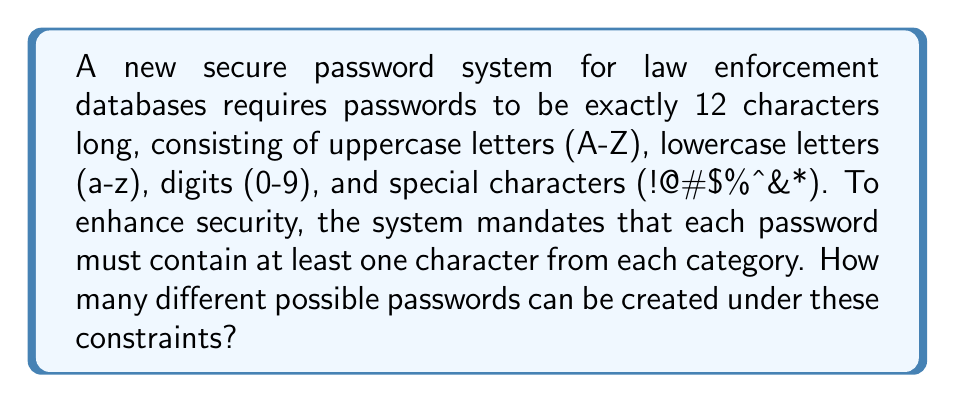Provide a solution to this math problem. Let's approach this step-by-step using the Principle of Inclusion-Exclusion:

1) First, let's count the total number of 12-character passwords without restrictions:
   $$(26 + 26 + 10 + 8)^{12} = 70^{12}$$

2) Now, we need to subtract the passwords that don't meet our criteria. Let's count the passwords missing at least one category:

   a) Missing uppercase: $$(26 + 10 + 8)^{12} = 44^{12}$$
   b) Missing lowercase: $$(26 + 10 + 8)^{12} = 44^{12}$$
   c) Missing digit: $$(26 + 26 + 8)^{12} = 60^{12}$$
   d) Missing special: $$(26 + 26 + 10)^{12} = 62^{12}$$

3) We've overcounted some passwords, so we need to add back those missing two categories:

   e) Missing uppercase and lowercase: $$(10 + 8)^{12} = 18^{12}$$
   f) Missing uppercase and digit: $$(26 + 8)^{12} = 34^{12}$$
   g) Missing uppercase and special: $$(26 + 10)^{12} = 36^{12}$$
   h) Missing lowercase and digit: $$(26 + 8)^{12} = 34^{12}$$
   i) Missing lowercase and special: $$(26 + 10)^{12} = 36^{12}$$
   j) Missing digit and special: $$(26 + 26)^{12} = 52^{12}$$

4) Now we've undercounted, so we need to subtract passwords missing three categories:

   k) Only lowercase: $$26^{12}$$
   l) Only uppercase: $$26^{12}$$
   m) Only digits: $$10^{12}$$
   n) Only special: $$8^{12}$$

5) Applying the Principle of Inclusion-Exclusion:

   $$\text{Total} = 70^{12} - (44^{12} + 44^{12} + 60^{12} + 62^{12}) + (18^{12} + 34^{12} + 36^{12} + 34^{12} + 36^{12} + 52^{12}) - (26^{12} + 26^{12} + 10^{12} + 8^{12})$$

6) Calculating this large number:

   $$\text{Total} = 3.385... \times 10^{22}$$
Answer: $$3.385 \times 10^{22}$$ 